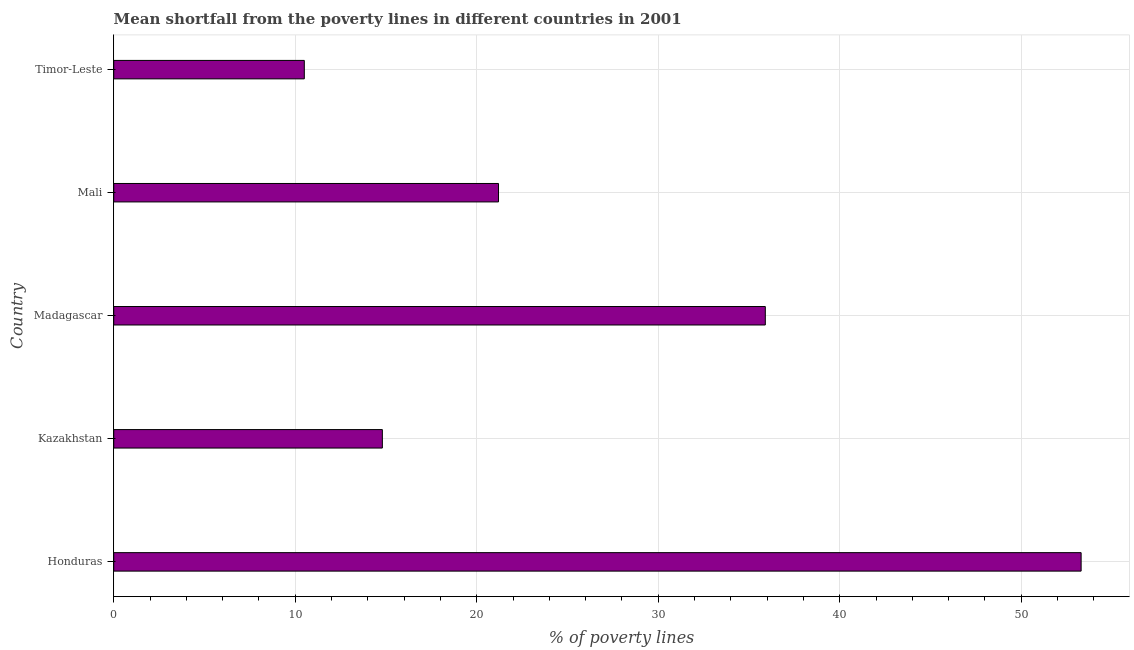What is the title of the graph?
Keep it short and to the point. Mean shortfall from the poverty lines in different countries in 2001. What is the label or title of the X-axis?
Offer a very short reply. % of poverty lines. What is the label or title of the Y-axis?
Your response must be concise. Country. What is the poverty gap at national poverty lines in Mali?
Your response must be concise. 21.2. Across all countries, what is the maximum poverty gap at national poverty lines?
Keep it short and to the point. 53.3. In which country was the poverty gap at national poverty lines maximum?
Make the answer very short. Honduras. In which country was the poverty gap at national poverty lines minimum?
Offer a very short reply. Timor-Leste. What is the sum of the poverty gap at national poverty lines?
Your response must be concise. 135.7. What is the difference between the poverty gap at national poverty lines in Madagascar and Mali?
Ensure brevity in your answer.  14.7. What is the average poverty gap at national poverty lines per country?
Your answer should be compact. 27.14. What is the median poverty gap at national poverty lines?
Provide a short and direct response. 21.2. What is the ratio of the poverty gap at national poverty lines in Honduras to that in Kazakhstan?
Offer a terse response. 3.6. Is the poverty gap at national poverty lines in Kazakhstan less than that in Mali?
Your answer should be compact. Yes. What is the difference between the highest and the second highest poverty gap at national poverty lines?
Offer a very short reply. 17.4. Is the sum of the poverty gap at national poverty lines in Madagascar and Mali greater than the maximum poverty gap at national poverty lines across all countries?
Your answer should be compact. Yes. What is the difference between the highest and the lowest poverty gap at national poverty lines?
Give a very brief answer. 42.8. How many bars are there?
Provide a succinct answer. 5. Are all the bars in the graph horizontal?
Offer a very short reply. Yes. What is the difference between two consecutive major ticks on the X-axis?
Ensure brevity in your answer.  10. What is the % of poverty lines in Honduras?
Your answer should be compact. 53.3. What is the % of poverty lines in Kazakhstan?
Your response must be concise. 14.8. What is the % of poverty lines in Madagascar?
Make the answer very short. 35.9. What is the % of poverty lines of Mali?
Ensure brevity in your answer.  21.2. What is the difference between the % of poverty lines in Honduras and Kazakhstan?
Your answer should be very brief. 38.5. What is the difference between the % of poverty lines in Honduras and Mali?
Provide a short and direct response. 32.1. What is the difference between the % of poverty lines in Honduras and Timor-Leste?
Provide a short and direct response. 42.8. What is the difference between the % of poverty lines in Kazakhstan and Madagascar?
Provide a succinct answer. -21.1. What is the difference between the % of poverty lines in Kazakhstan and Mali?
Provide a succinct answer. -6.4. What is the difference between the % of poverty lines in Madagascar and Timor-Leste?
Your response must be concise. 25.4. What is the ratio of the % of poverty lines in Honduras to that in Kazakhstan?
Offer a terse response. 3.6. What is the ratio of the % of poverty lines in Honduras to that in Madagascar?
Provide a succinct answer. 1.49. What is the ratio of the % of poverty lines in Honduras to that in Mali?
Offer a very short reply. 2.51. What is the ratio of the % of poverty lines in Honduras to that in Timor-Leste?
Your answer should be compact. 5.08. What is the ratio of the % of poverty lines in Kazakhstan to that in Madagascar?
Keep it short and to the point. 0.41. What is the ratio of the % of poverty lines in Kazakhstan to that in Mali?
Keep it short and to the point. 0.7. What is the ratio of the % of poverty lines in Kazakhstan to that in Timor-Leste?
Your response must be concise. 1.41. What is the ratio of the % of poverty lines in Madagascar to that in Mali?
Offer a very short reply. 1.69. What is the ratio of the % of poverty lines in Madagascar to that in Timor-Leste?
Offer a very short reply. 3.42. What is the ratio of the % of poverty lines in Mali to that in Timor-Leste?
Provide a short and direct response. 2.02. 